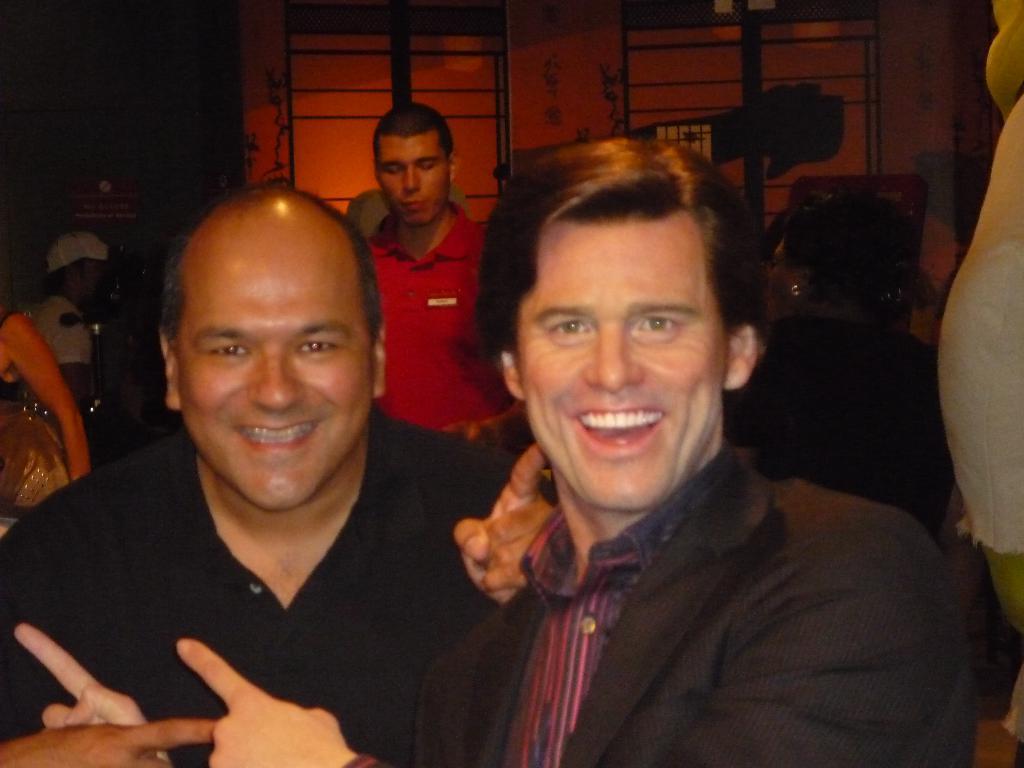Describe this image in one or two sentences. In this image we can see two men are smiling. In the background there are few persons and the image is not clear to describe but we can see objects. 